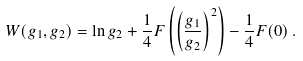Convert formula to latex. <formula><loc_0><loc_0><loc_500><loc_500>W ( g _ { 1 } , g _ { 2 } ) = \ln g _ { 2 } + \frac { 1 } { 4 } F \left ( \left ( \frac { g _ { 1 } } { g _ { 2 } } \right ) ^ { 2 } \right ) - \frac { 1 } { 4 } F ( 0 ) \, .</formula> 